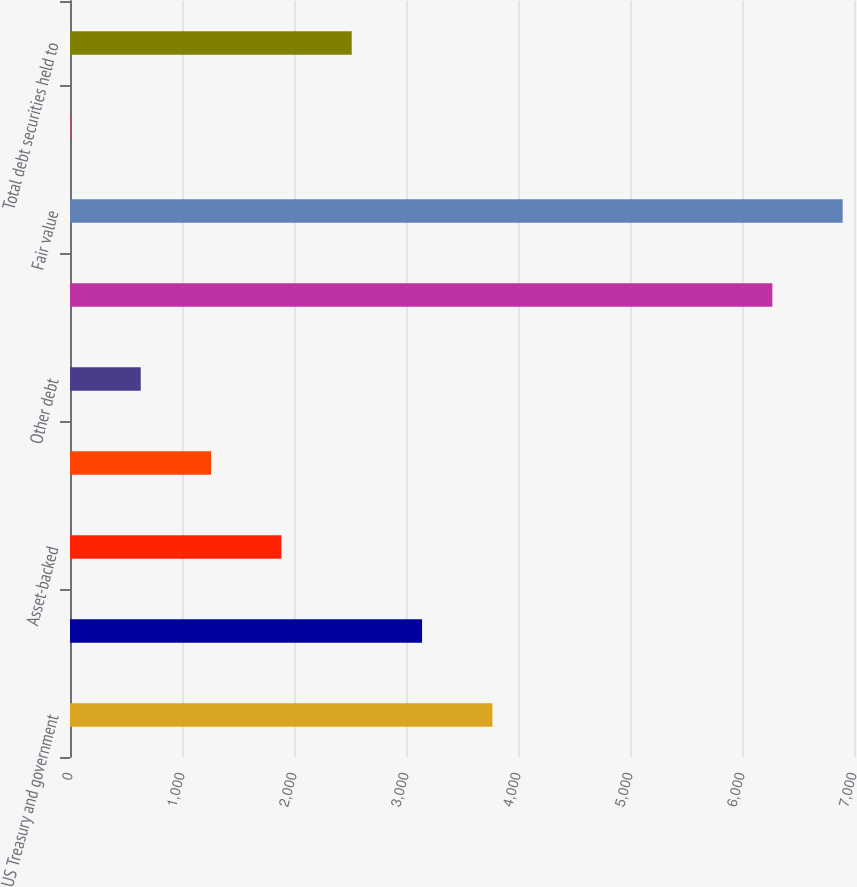Convert chart to OTSL. <chart><loc_0><loc_0><loc_500><loc_500><bar_chart><fcel>US Treasury and government<fcel>Agency<fcel>Asset-backed<fcel>State and municipal<fcel>Other debt<fcel>Total debt securities<fcel>Fair value<fcel>Weighted-average yield GAAP<fcel>Total debt securities held to<nl><fcel>3771.31<fcel>3143.38<fcel>1887.53<fcel>1259.61<fcel>631.68<fcel>6271<fcel>6898.93<fcel>3.75<fcel>2515.45<nl></chart> 